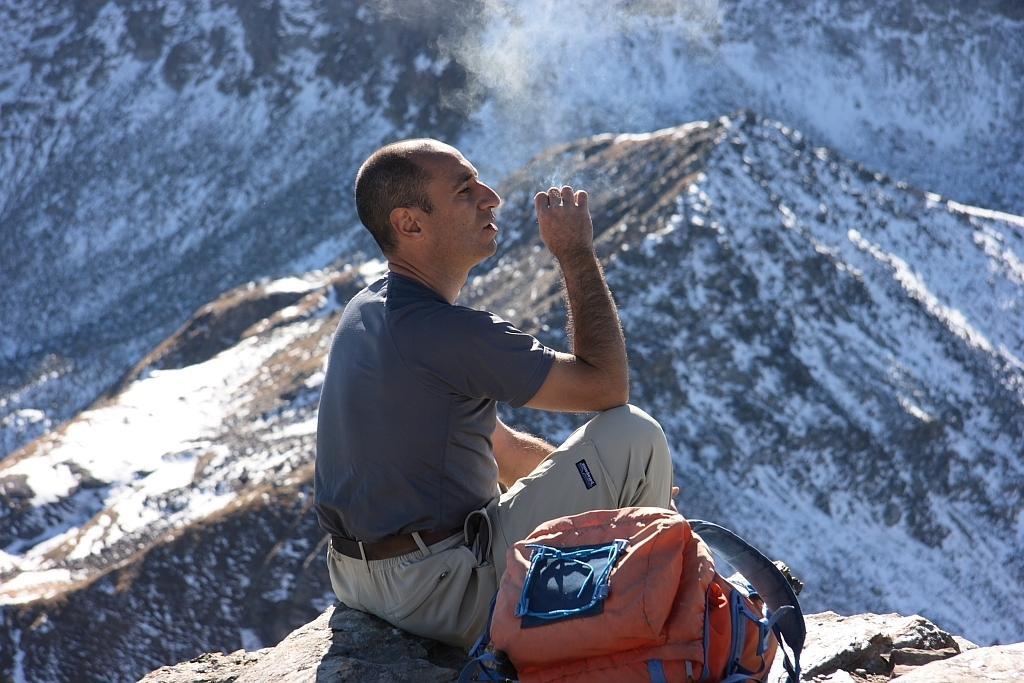How would you summarize this image in a sentence or two? In this image a person is sitting on a rock having a bag beside him. Behind him there are few hills covered with snow. 